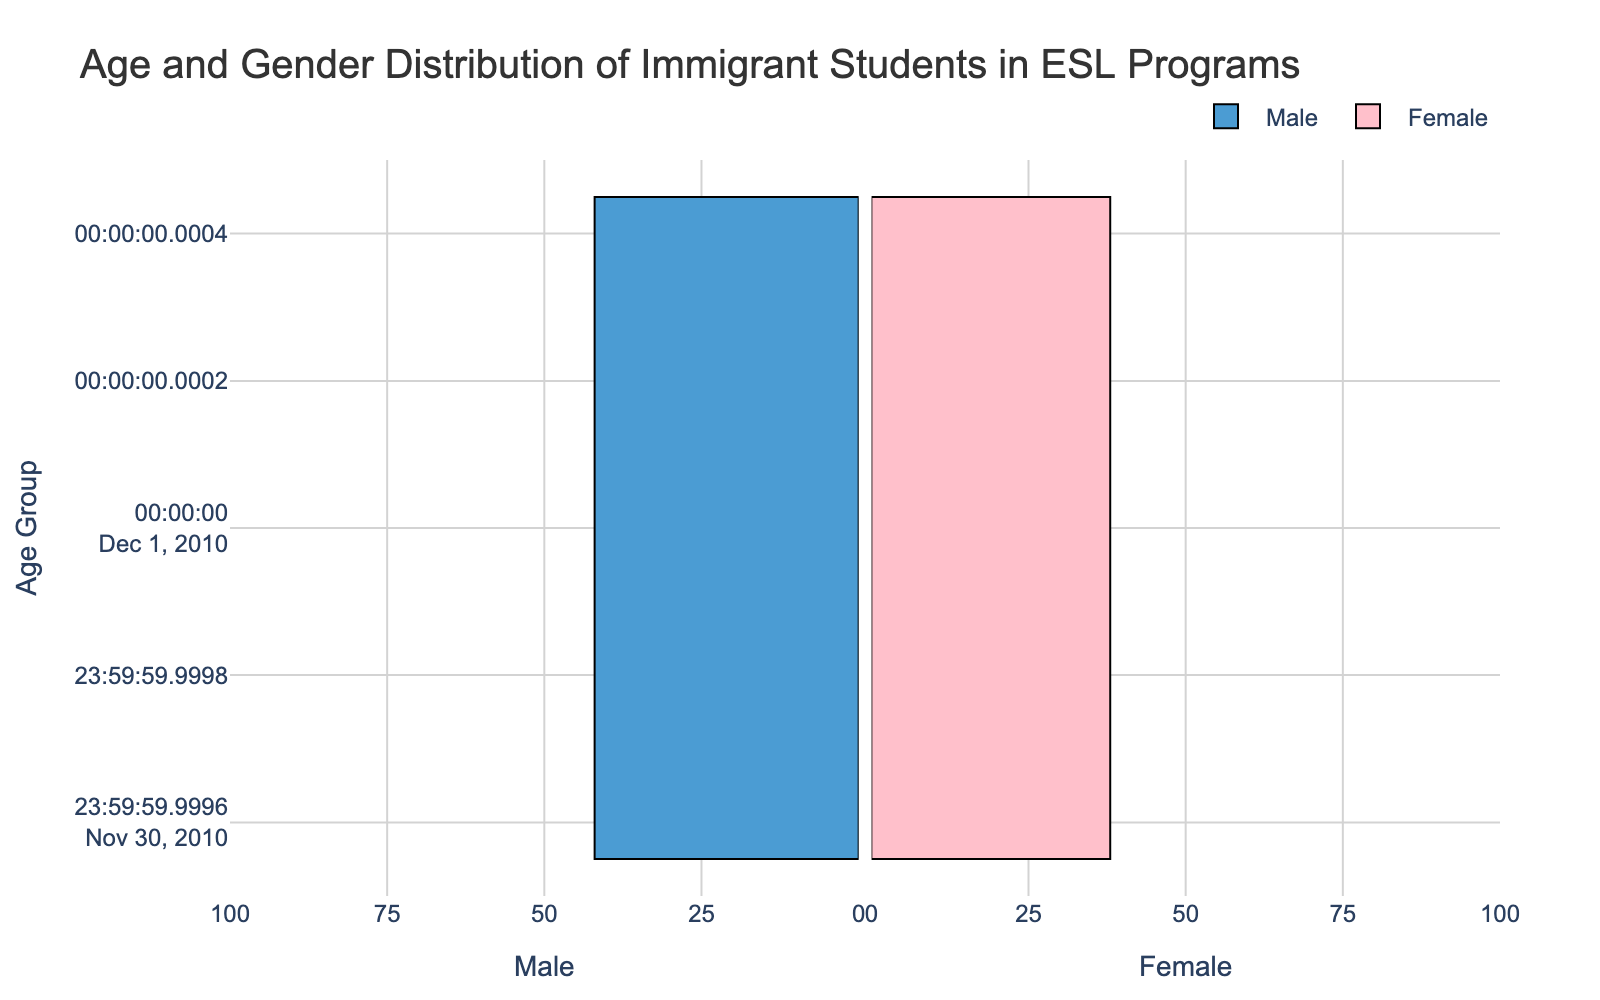What is the title of the plot? The title is located at the top of the plot, which provides an overall idea about what the figure represents.
Answer: Age and Gender Distribution of Immigrant Students in ESL Programs How many age groups are represented in the plot? Count the number of distinct age groups listed on the y-axis of the plot.
Answer: 5 Which age group has the highest number of male students? Look at the horizontal bars on the left side of the plot and identify which age group has the longest bar.
Answer: 15-16 How many female students are in the 17-18 age group? Look at the horizontal bar corresponding to females in the 17-18 age group and read the value on the x-axis.
Answer: 79 What is the total number of students (both male and female) in the 10-12 age group? Add the male and female values for the 10-12 age group (42 male + 38 female).
Answer: 80 Are there more male or female students in the 13-14 age group? Compare the lengths of the male and female bars for the 13-14 age group to see which bar is longer.
Answer: Female What is the difference in the number of students between the 15-16 age group and the 19-20 age group? First, calculate the total number of students in each age group, then subtract the total number of students in the 19-20 age group from the total in the 15-16 age group. (15-16: 89 male + 95 female = 184; 19-20: 31 male + 27 female = 58; Difference: 184 - 58)
Answer: 126 Which age group has the smallest gender difference in student numbers? Calculate the absolute difference between the number of male and female students for each age group and identify the age group with the smallest difference.
Answer: 19-20 By looking at the plot, which gender has a higher overall participation in ESL programs across all age groups? Visually sum the lengths of the bars for each gender across all age groups and determine which gender has longer total bars.
Answer: Female 